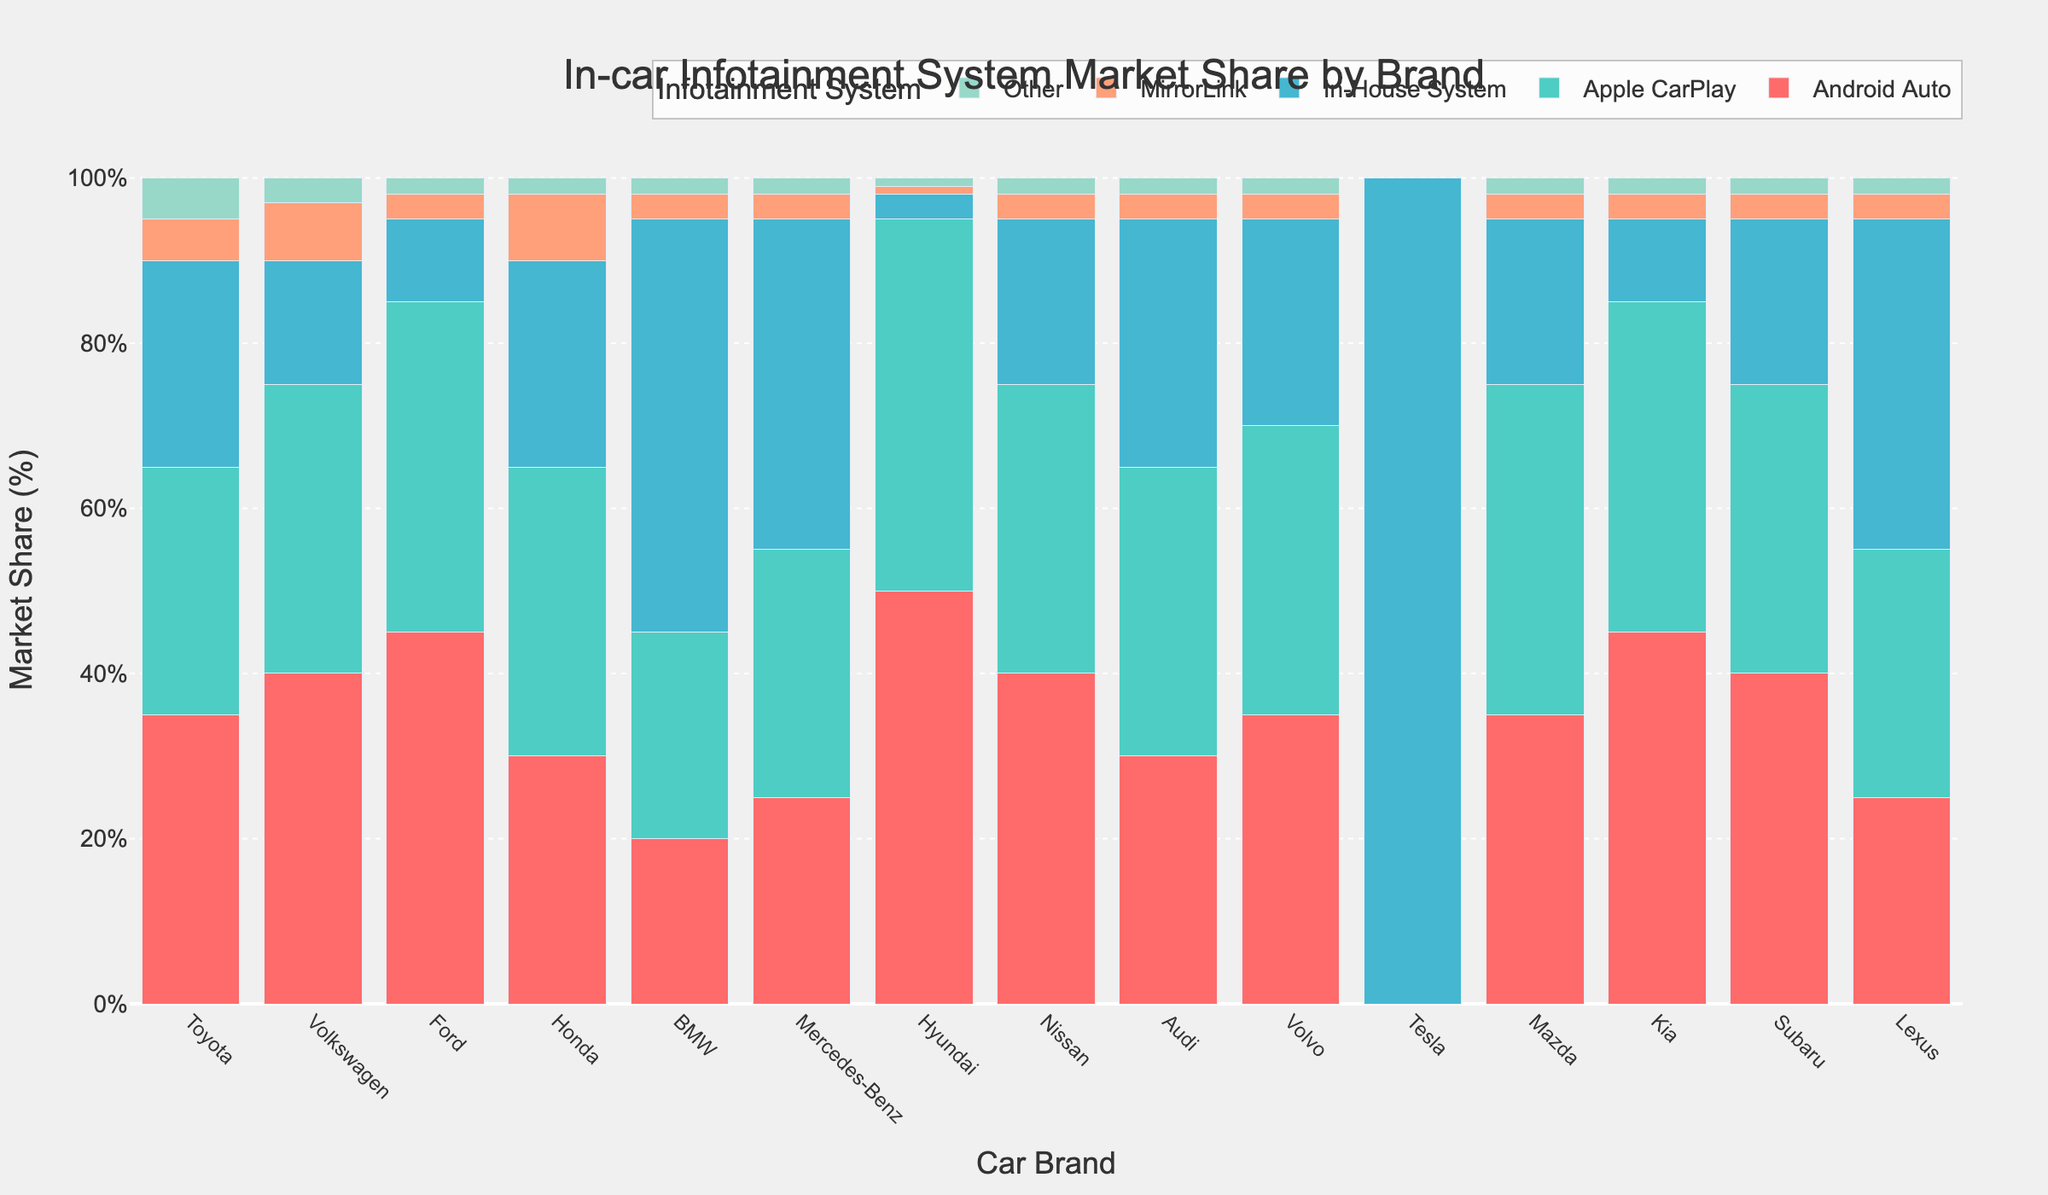What brand has the highest market share for Apple CarPlay? By looking at the height of the bars corresponding to Apple CarPlay, the highest one is for Hyundai.
Answer: Hyundai Which brand has the lowest market share for Android Auto? By comparing the heights of the bars corresponding to Android Auto, Tesla has the lowest market share at 0%.
Answer: Tesla What is the total market share of in-house systems for BMW and Mercedes-Benz combined? The market shares for in-house systems are 50% for BMW and 40% for Mercedes-Benz. Adding them up, we get 50 + 40 = 90.
Answer: 90% Which system has the highest market share across all brands? By looking at the color-coded bars, the in-house system for Tesla stands out at 100%.
Answer: Tesla's in-house system How does the market share for MirrorLink in Toyota compare to Hyundai? Toyota's market share for MirrorLink is 5% while Hyundai's is 1%. 5% is greater than 1%.
Answer: Toyota > Hyundai What is the average market share of other systems across all brands? To find this, we add the market shares of other systems for each brand and divide by the number of brands: (5+3+2+2+2+2+1+2+2+2+0+2+2+2+2)/15 = 2.13%.
Answer: 2.13% Which brand(s) have an equal market share for Android Auto and Apple CarPlay? Looking at the bars, Honda, Nissan, Audi, and Volvo all have an equal market share for Android Auto and Apple CarPlay at 30% each.
Answer: Honda, Nissan, Audi, Volvo What's the difference in market share for Apple CarPlay between Mazda and Kia? The market share for Apple CarPlay is 40% for both Mazda and Kia, so the difference is 40 - 40 = 0%.
Answer: 0% Which brands have a higher market share for in-house systems compared to Apple CarPlay? The brands with higher market shares for in-house systems than Apple CarPlay are BMW (50% vs 25%), Mercedes-Benz (40% vs 30%), Lexus (40% vs 30%), and Tesla (100% vs 0%).
Answer: BMW, Mercedes-Benz, Lexus, Tesla What is the combined market share for MirrorLink and Other systems in Volkswagen? The market shares for MirrorLink and Other systems in Volkswagen are 7% and 3%, respectively. Adding them up, we get 7 + 3 = 10%.
Answer: 10% 